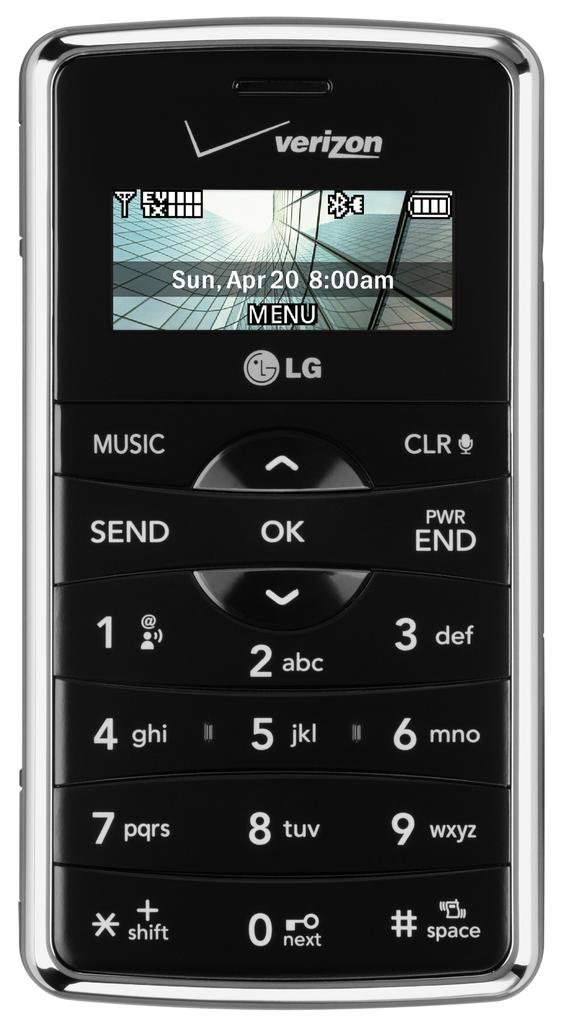What is the main subject of the image? The main subject of the image is a picture of a mobile phone. Can you identify the brand of the mobile phone? Yes, the mobile phone is from the LG company. How much income does the mobile phone generate in the image? The image does not provide information about the income generated by the mobile phone. What type of string is attached to the mobile phone in the image? There is no string attached to the mobile phone in the image. 